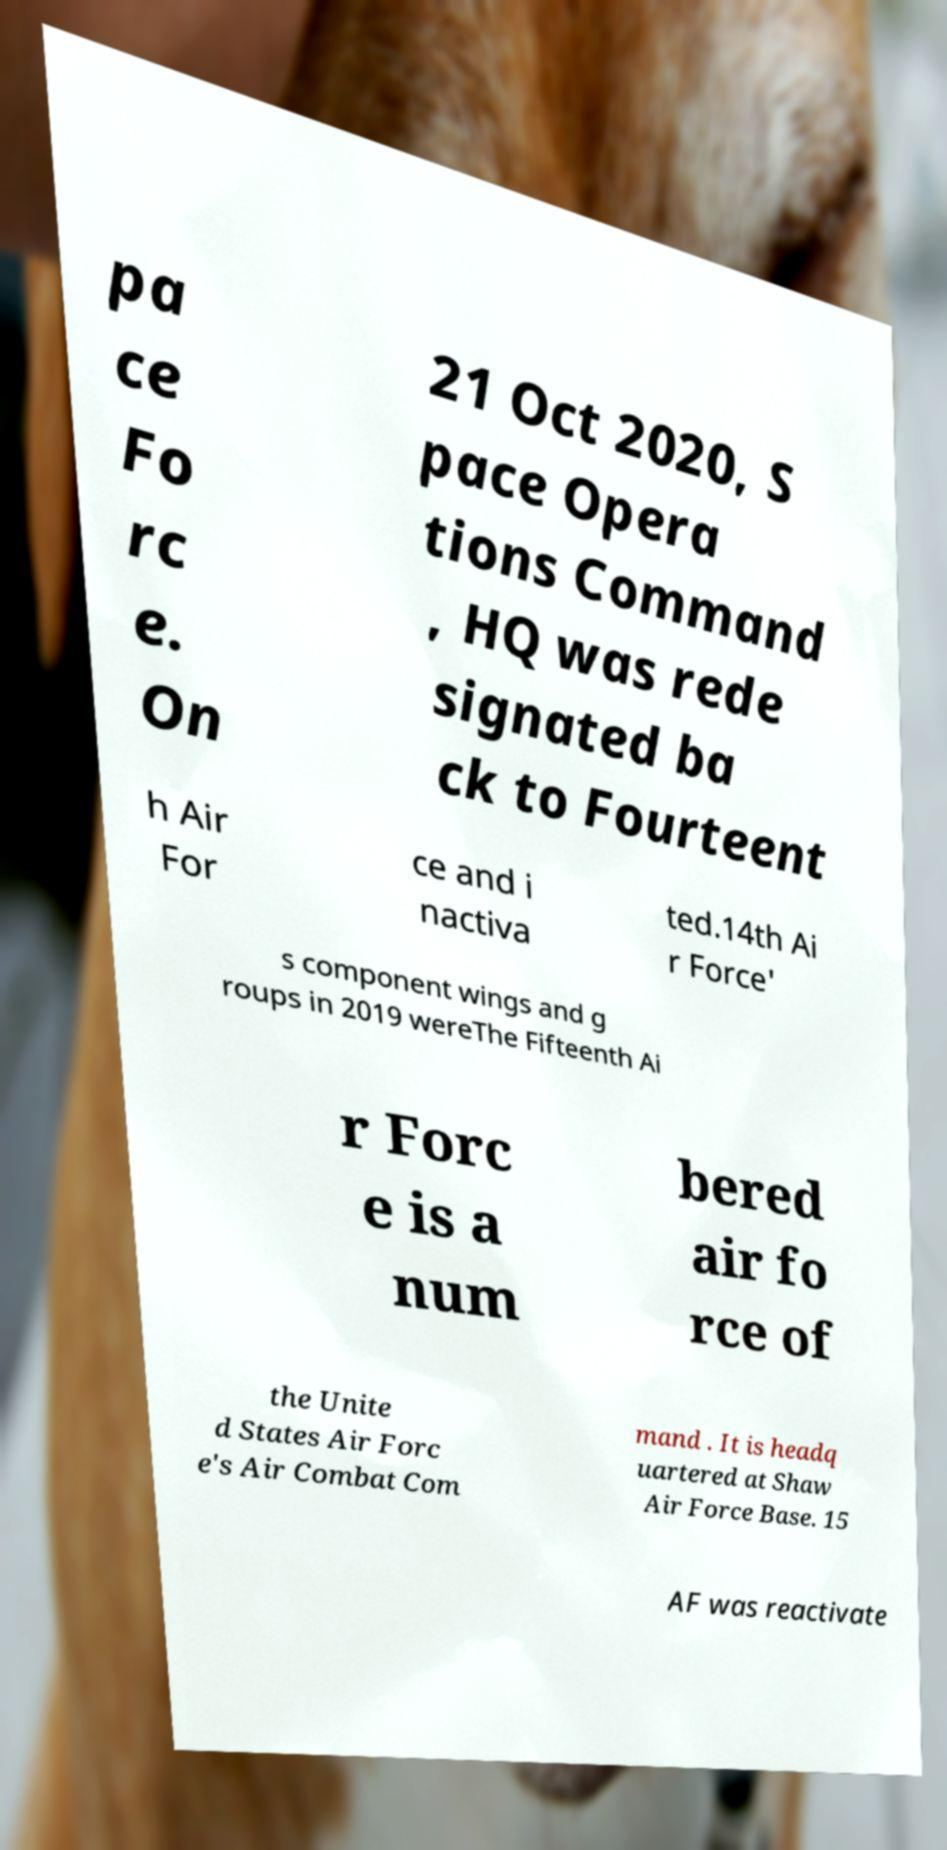Please identify and transcribe the text found in this image. pa ce Fo rc e. On 21 Oct 2020, S pace Opera tions Command , HQ was rede signated ba ck to Fourteent h Air For ce and i nactiva ted.14th Ai r Force' s component wings and g roups in 2019 wereThe Fifteenth Ai r Forc e is a num bered air fo rce of the Unite d States Air Forc e's Air Combat Com mand . It is headq uartered at Shaw Air Force Base. 15 AF was reactivate 